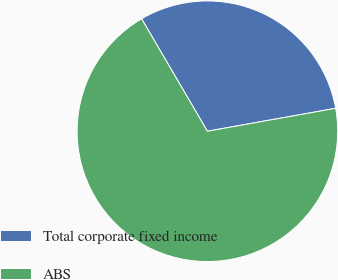<chart> <loc_0><loc_0><loc_500><loc_500><pie_chart><fcel>Total corporate fixed income<fcel>ABS<nl><fcel>30.61%<fcel>69.39%<nl></chart> 